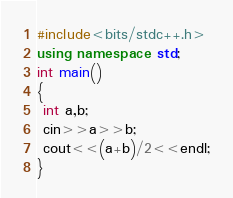<code> <loc_0><loc_0><loc_500><loc_500><_C++_>#include<bits/stdc++.h>
using namespace std;
int main()
{
 int a,b;
 cin>>a>>b;
 cout<<(a+b)/2<<endl;
}
</code> 